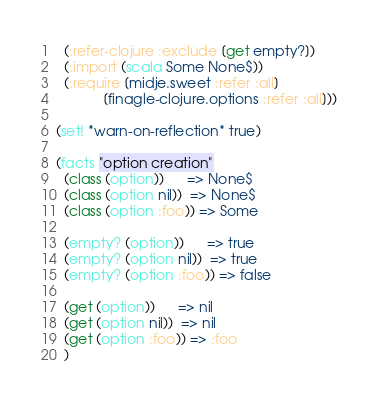<code> <loc_0><loc_0><loc_500><loc_500><_Clojure_>  (:refer-clojure :exclude [get empty?])
  (:import (scala Some None$))
  (:require [midje.sweet :refer :all]
            [finagle-clojure.options :refer :all]))

(set! *warn-on-reflection* true)

(facts "option creation"
  (class (option))      => None$
  (class (option nil))  => None$
  (class (option :foo)) => Some

  (empty? (option))      => true
  (empty? (option nil))  => true
  (empty? (option :foo)) => false

  (get (option))      => nil
  (get (option nil))  => nil
  (get (option :foo)) => :foo
  )
</code> 